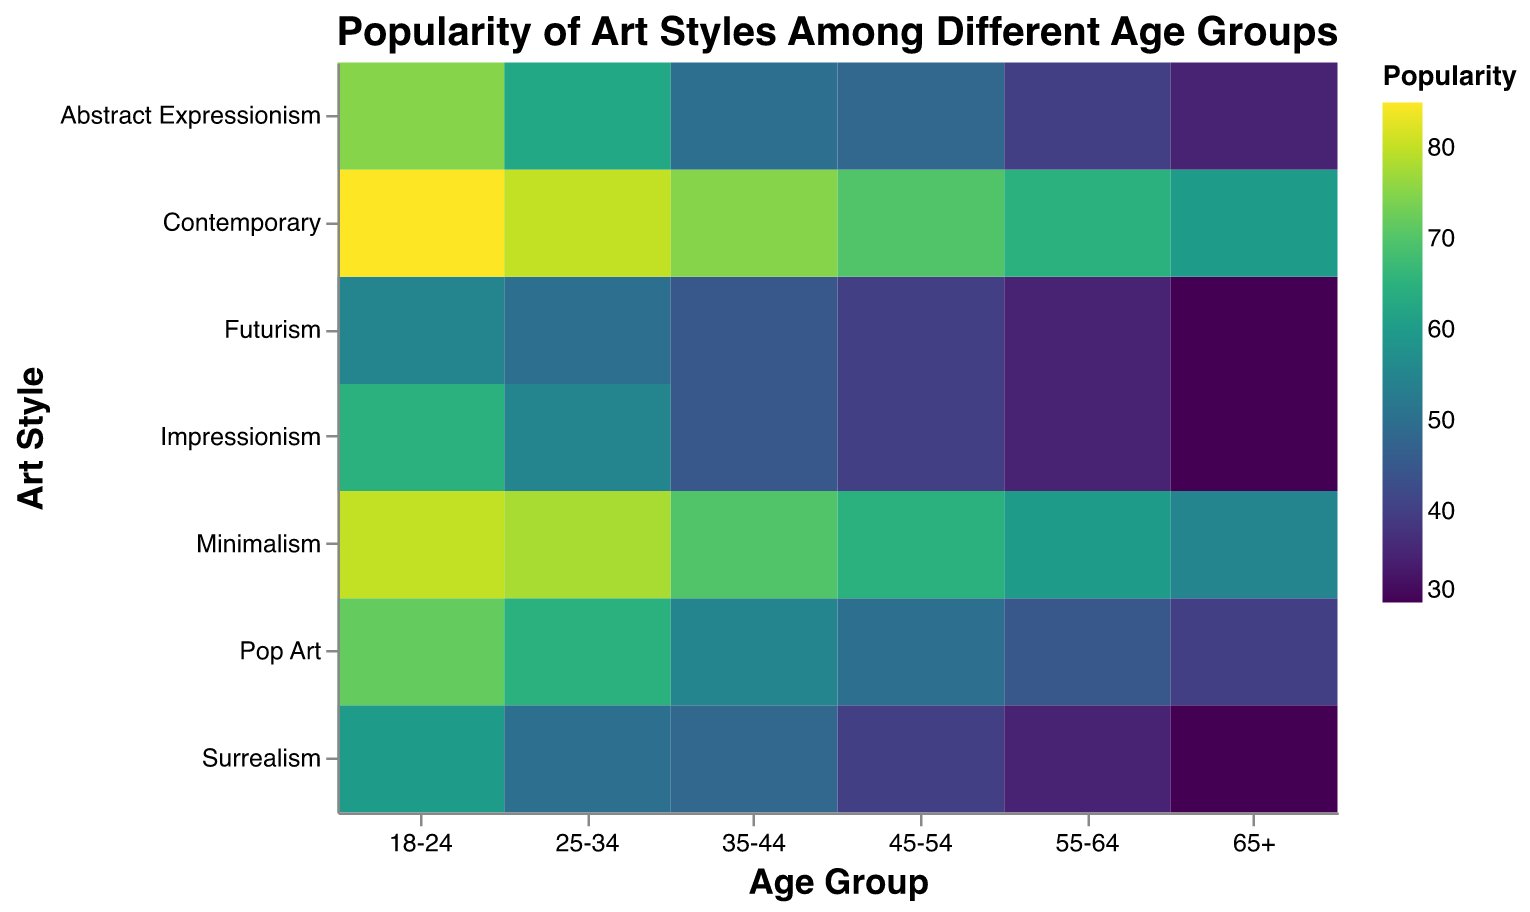What's the most popular art style among the 18-24 age group? From the heatmap, we look for the highest value in the 18-24 age group row. The highest popularity value is 85. We trace it to Contemporary art style.
Answer: Contemporary Which age group shows the least interest in Impressionism? By examining the heatmap, we identify the lowest value in the Impressionism column. The lowest value is 30, which corresponds to the 65+ age group.
Answer: 65+ How does the popularity of Minimalism change across different age groups? Observing the values in the Minimalism row for different age groups: 80, 78, 70, 65, 60, 55, we see a decreasing trend as age increases.
Answer: Decreases Compare the popularity of Surrealism between the 18-24 and 35-44 age groups. Which group has a higher preference? In the heatmap, we identify the values of Surrealism for 18-24 and 35-44 age groups: 60 and 48, respectively. 60 is higher than 48.
Answer: 18-24 What is the average popularity of Pop Art across all age groups? We sum up the popularity values of Pop Art for all age groups: 72 + 65 + 55 + 50 + 45 + 40 = 327. Then we divide by the number of age groups, 6. The average is 327 / 6.
Answer: 54.5 Which art style sees a constant decrease in popularity as age increases? By visually inspecting the heatmap, we look for a column where the values consistently decrease as age increases. The Abstract Expressionism column shows this pattern: 75, 63, 50, 48, 40, 35.
Answer: Abstract Expressionism What is the difference in the popularity of Contemporary art between the youngest and oldest age groups? From the heatmap, we find the Contemporary art popularity values for 18-24 and 65+: 85 and 60, respectively. The difference is 85 - 60.
Answer: 25 Does any age group prefer Futurism the most compared to other art styles? By observing each age group's row, we check if the highest value falls under the Futurism column. No row has its highest value in the Futurism column.
Answer: No Which age group has the closest popularity scores between Abstract Expressionism and Surrealism? We find the differences between the values of Abstract Expressionism and Surrealism for each age group: 15, 13, 2, 8, 5, 5. The smallest difference is 2 for the 35-44 age group.
Answer: 35-44 